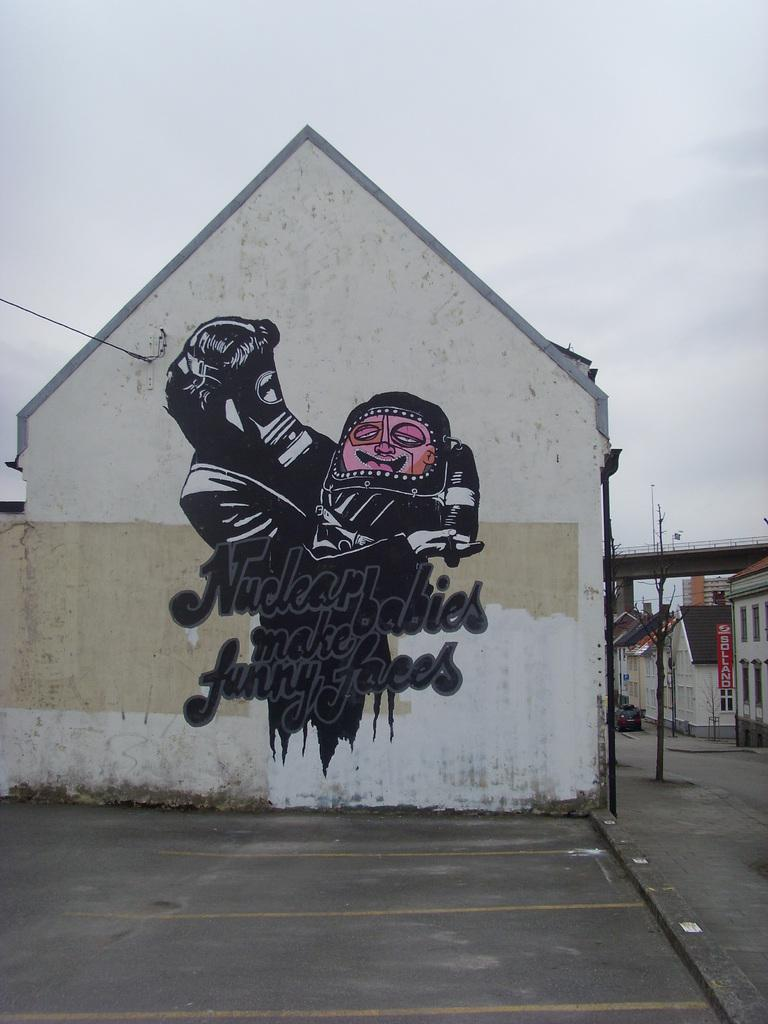<image>
Summarize the visual content of the image. the vertical red sign next to house says Sollano 